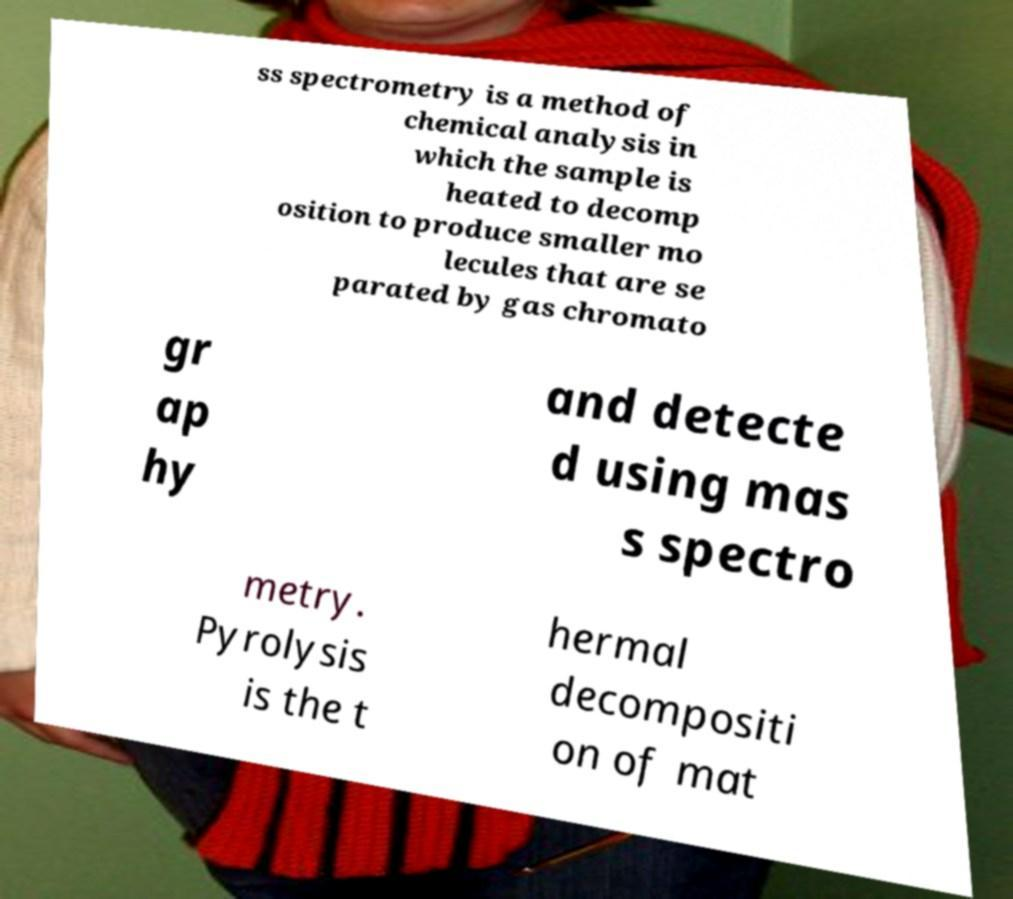Please read and relay the text visible in this image. What does it say? ss spectrometry is a method of chemical analysis in which the sample is heated to decomp osition to produce smaller mo lecules that are se parated by gas chromato gr ap hy and detecte d using mas s spectro metry. Pyrolysis is the t hermal decompositi on of mat 